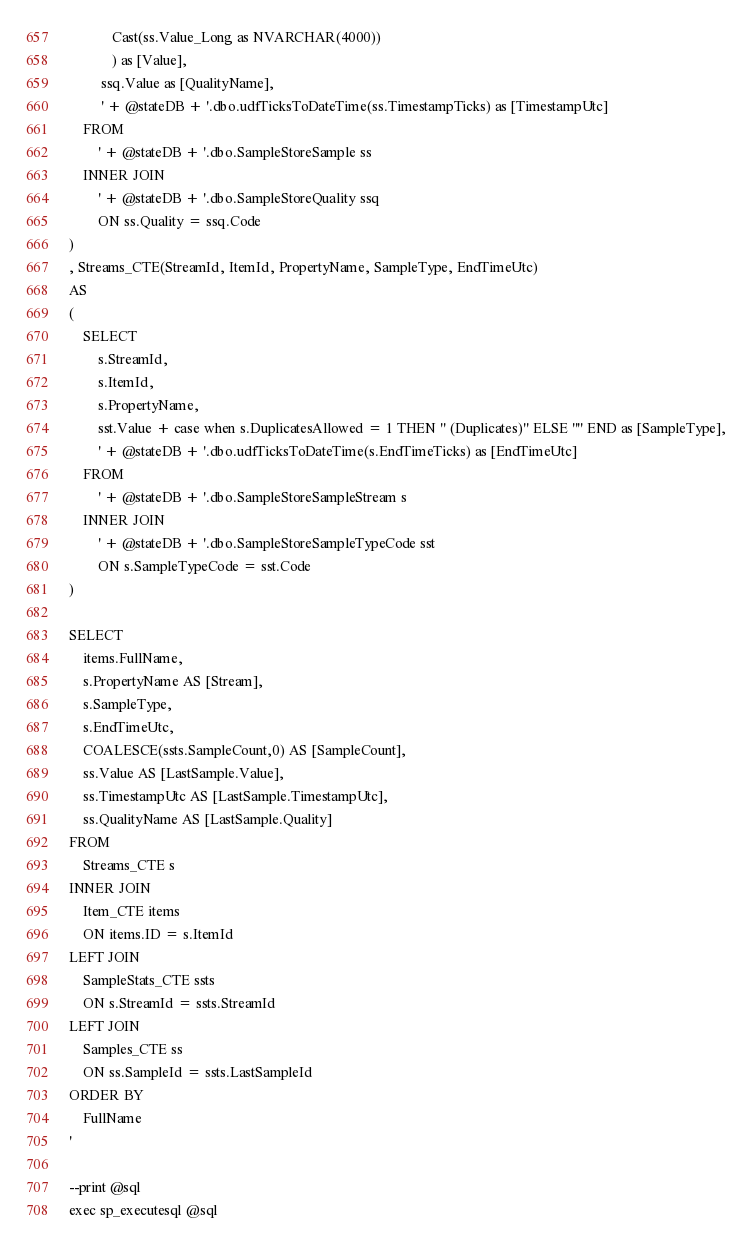<code> <loc_0><loc_0><loc_500><loc_500><_SQL_>			Cast(ss.Value_Long as NVARCHAR(4000))
			) as [Value],
		 ssq.Value as [QualityName],
		 ' + @stateDB + '.dbo.udfTicksToDateTime(ss.TimestampTicks) as [TimestampUtc]
	FROM 
		' + @stateDB + '.dbo.SampleStoreSample ss
	INNER JOIN 
		' + @stateDB + '.dbo.SampleStoreQuality ssq
		ON ss.Quality = ssq.Code
)
, Streams_CTE(StreamId, ItemId, PropertyName, SampleType, EndTimeUtc)
AS 
(
	SELECT 
		s.StreamId,
		s.ItemId,
		s.PropertyName,
		sst.Value + case when s.DuplicatesAllowed = 1 THEN '' (Duplicates)'' ELSE '''' END as [SampleType],
		' + @stateDB + '.dbo.udfTicksToDateTime(s.EndTimeTicks) as [EndTimeUtc]
	FROM 
		' + @stateDB + '.dbo.SampleStoreSampleStream s
	INNER JOIN 
		' + @stateDB + '.dbo.SampleStoreSampleTypeCode sst
		ON s.SampleTypeCode = sst.Code
)

SELECT 
	items.FullName,
	s.PropertyName AS [Stream],
	s.SampleType,
	s.EndTimeUtc,
	COALESCE(ssts.SampleCount,0) AS [SampleCount],
	ss.Value AS [LastSample.Value],
	ss.TimestampUtc AS [LastSample.TimestampUtc], 
	ss.QualityName AS [LastSample.Quality]
FROM
	Streams_CTE s
INNER JOIN 
	Item_CTE items
	ON items.ID = s.ItemId
LEFT JOIN 
	SampleStats_CTE ssts
	ON s.StreamId = ssts.StreamId
LEFT JOIN 
	Samples_CTE ss
	ON ss.SampleId = ssts.LastSampleId
ORDER BY
	FullName
'

--print @sql
exec sp_executesql @sql


</code> 